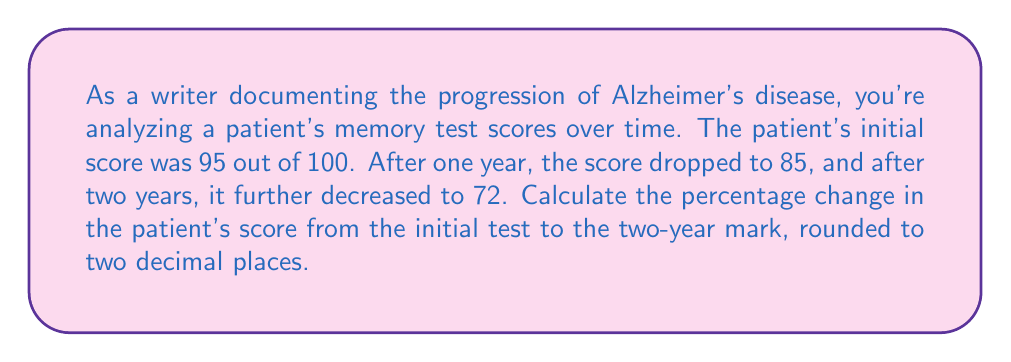What is the answer to this math problem? To calculate the percentage change in the patient's score from the initial test to the two-year mark, we'll use the following formula:

$$ \text{Percentage Change} = \frac{\text{Final Value} - \text{Initial Value}}{\text{Initial Value}} \times 100\% $$

Given:
- Initial score: 95
- Score after two years: 72

Let's plug these values into the formula:

$$ \text{Percentage Change} = \frac{72 - 95}{95} \times 100\% $$

$$ = \frac{-23}{95} \times 100\% $$

$$ = -0.2421052631578947 \times 100\% $$

$$ = -24.21052631578947\% $$

Rounding to two decimal places:

$$ = -24.21\% $$

The negative sign indicates a decrease in the score.
Answer: $-24.21\%$ 